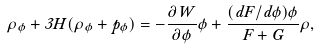<formula> <loc_0><loc_0><loc_500><loc_500>\dot { \rho } _ { \phi } + 3 H ( \rho _ { \phi } + p _ { \phi } ) = - \frac { \partial W } { \partial \phi } \dot { \phi } + \frac { ( d F / d \phi ) \dot { \phi } } { F + G } \rho ,</formula> 